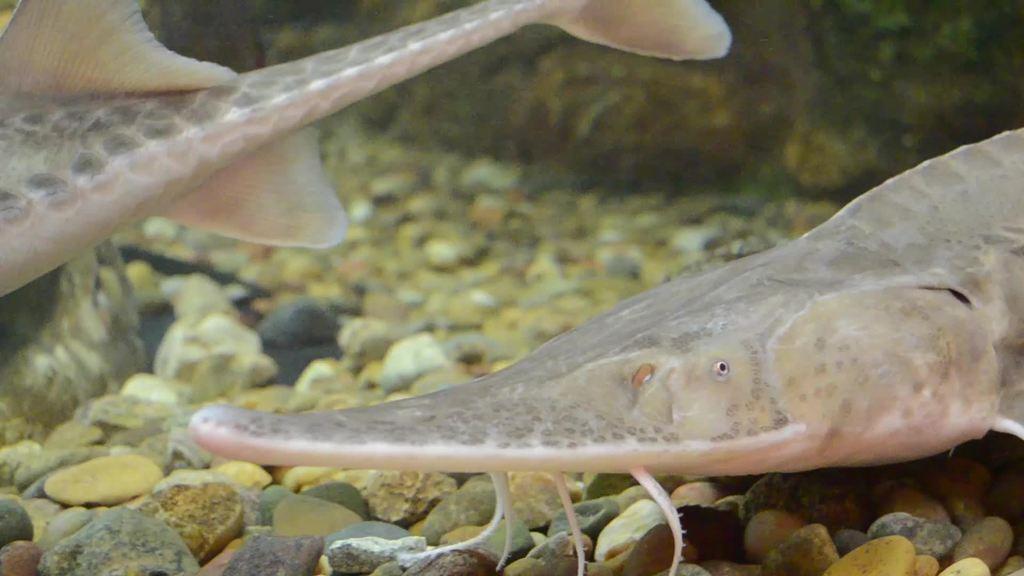Could you give a brief overview of what you see in this image? In this picture I can observe two fish swimming in the water. In the background I can observe stones. 